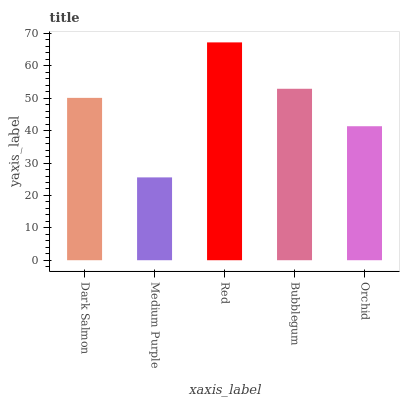Is Medium Purple the minimum?
Answer yes or no. Yes. Is Red the maximum?
Answer yes or no. Yes. Is Red the minimum?
Answer yes or no. No. Is Medium Purple the maximum?
Answer yes or no. No. Is Red greater than Medium Purple?
Answer yes or no. Yes. Is Medium Purple less than Red?
Answer yes or no. Yes. Is Medium Purple greater than Red?
Answer yes or no. No. Is Red less than Medium Purple?
Answer yes or no. No. Is Dark Salmon the high median?
Answer yes or no. Yes. Is Dark Salmon the low median?
Answer yes or no. Yes. Is Medium Purple the high median?
Answer yes or no. No. Is Medium Purple the low median?
Answer yes or no. No. 